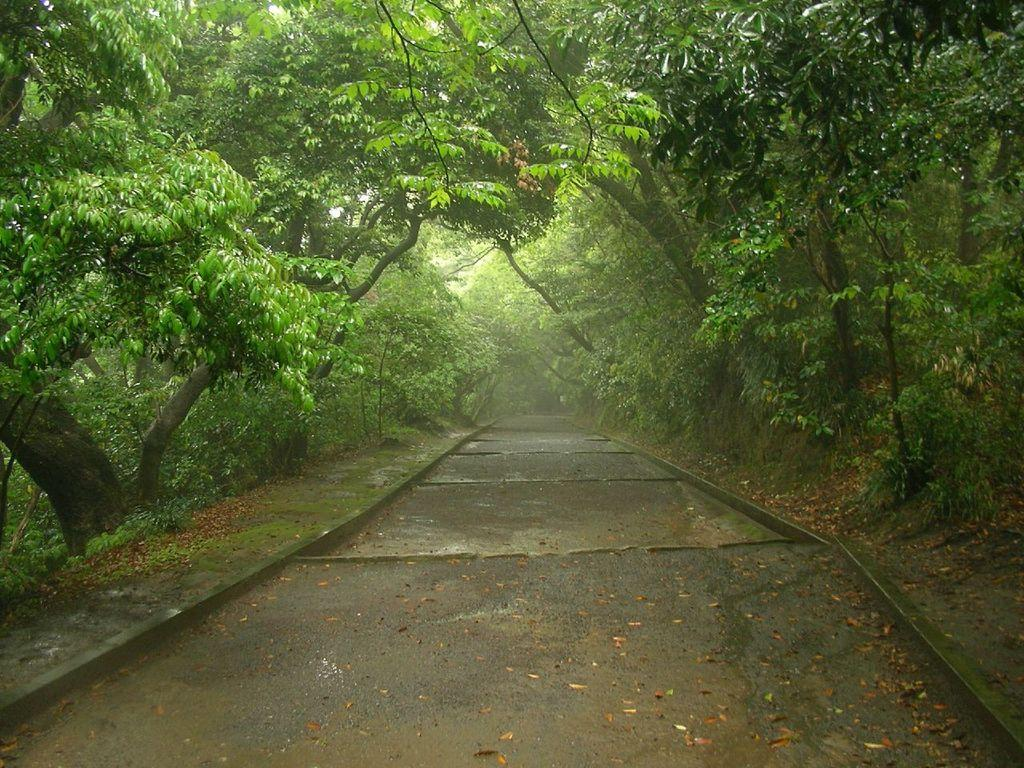What is the main subject of the image? The main subject of the image is a road. What can be seen on the sides of the road in the image? There are trees on the sides of the road in the image. Can you see a turkey walking along the road in the image? There is no turkey present in the image. What type of elbow is visible in the image? There is no elbow present in the image. 